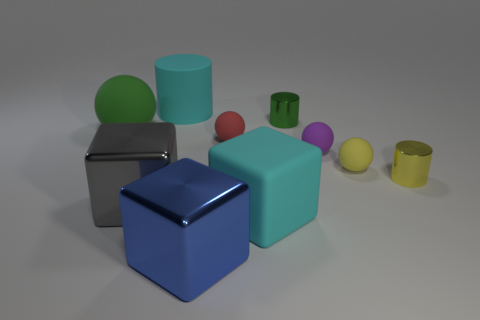Subtract all green balls. Subtract all purple cylinders. How many balls are left? 3 Subtract all cylinders. How many objects are left? 7 Subtract 0 red blocks. How many objects are left? 10 Subtract all small red balls. Subtract all metal cubes. How many objects are left? 7 Add 2 red spheres. How many red spheres are left? 3 Add 8 purple metal spheres. How many purple metal spheres exist? 8 